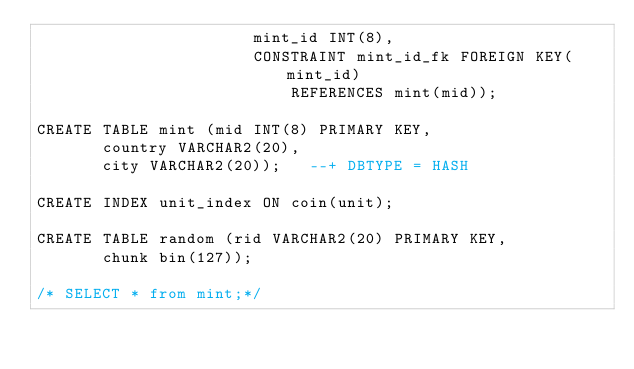Convert code to text. <code><loc_0><loc_0><loc_500><loc_500><_SQL_>                       mint_id INT(8),
                       CONSTRAINT mint_id_fk FOREIGN KEY(mint_id)
                           REFERENCES mint(mid));

CREATE TABLE mint (mid INT(8) PRIMARY KEY,
       country VARCHAR2(20),
       city VARCHAR2(20));   --+ DBTYPE = HASH

CREATE INDEX unit_index ON coin(unit);

CREATE TABLE random (rid VARCHAR2(20) PRIMARY KEY,
       chunk bin(127));

/* SELECT * from mint;*/  
</code> 